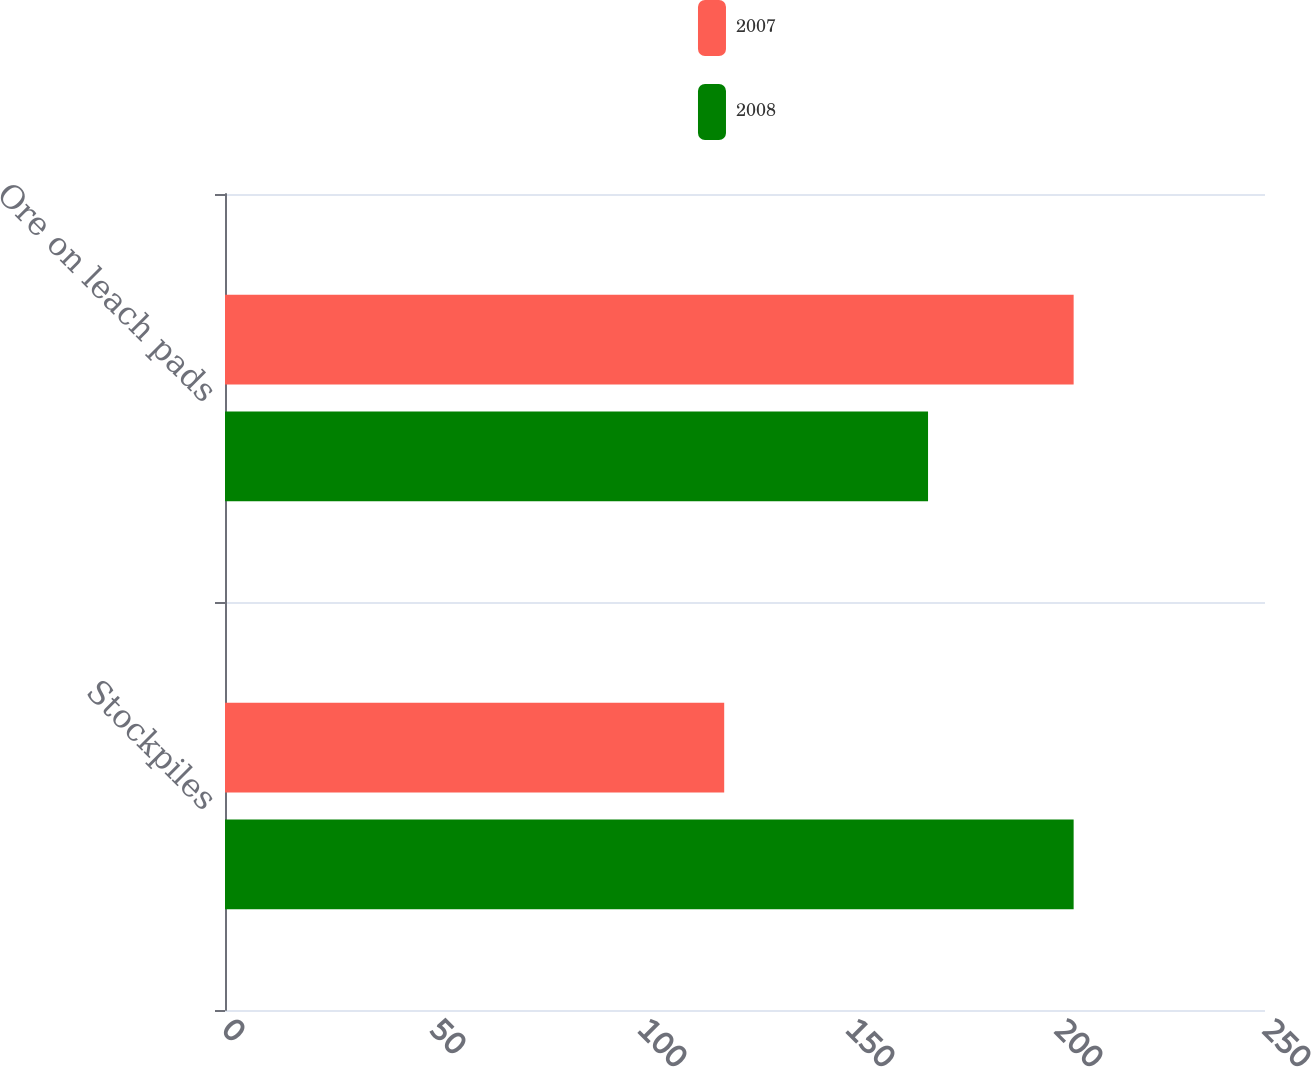Convert chart to OTSL. <chart><loc_0><loc_0><loc_500><loc_500><stacked_bar_chart><ecel><fcel>Stockpiles<fcel>Ore on leach pads<nl><fcel>2007<fcel>120<fcel>204<nl><fcel>2008<fcel>204<fcel>169<nl></chart> 